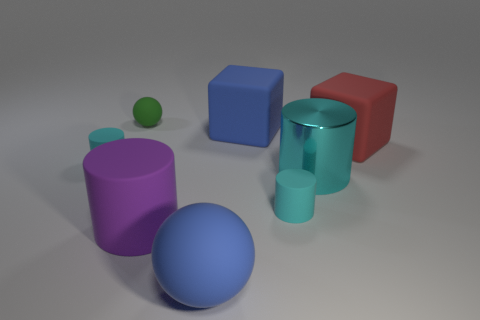Are there more cyan rubber cylinders than tiny metal cubes?
Ensure brevity in your answer.  Yes. There is a tiny thing that is behind the big red thing; is it the same color as the large cylinder that is to the left of the blue cube?
Make the answer very short. No. There is a blue matte object in front of the purple cylinder; are there any matte spheres that are right of it?
Give a very brief answer. No. Is the number of small spheres that are on the right side of the blue block less than the number of big cyan cylinders on the left side of the small green ball?
Make the answer very short. No. Is the material of the tiny cyan cylinder on the right side of the big rubber cylinder the same as the small cyan thing behind the big cyan object?
Give a very brief answer. Yes. How many large objects are rubber objects or brown cylinders?
Offer a terse response. 4. There is a green thing that is the same material as the red object; what shape is it?
Your response must be concise. Sphere. Are there fewer small green matte things in front of the blue matte ball than large purple things?
Your answer should be very brief. Yes. Is the big cyan shiny thing the same shape as the green thing?
Keep it short and to the point. No. How many matte objects are either large blue balls or big blue blocks?
Provide a succinct answer. 2. 